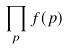Convert formula to latex. <formula><loc_0><loc_0><loc_500><loc_500>\prod _ { p } f ( p )</formula> 